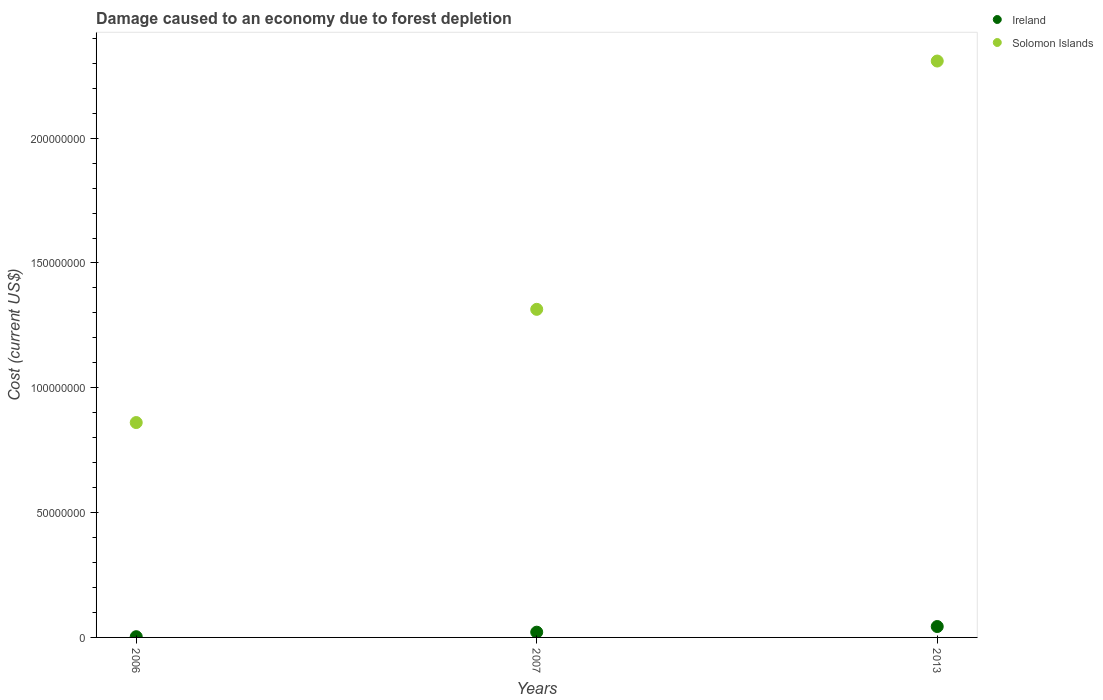Is the number of dotlines equal to the number of legend labels?
Offer a terse response. Yes. What is the cost of damage caused due to forest depletion in Ireland in 2007?
Offer a very short reply. 2.10e+06. Across all years, what is the maximum cost of damage caused due to forest depletion in Solomon Islands?
Provide a short and direct response. 2.31e+08. Across all years, what is the minimum cost of damage caused due to forest depletion in Solomon Islands?
Keep it short and to the point. 8.61e+07. In which year was the cost of damage caused due to forest depletion in Ireland maximum?
Offer a very short reply. 2013. What is the total cost of damage caused due to forest depletion in Ireland in the graph?
Your response must be concise. 6.76e+06. What is the difference between the cost of damage caused due to forest depletion in Solomon Islands in 2007 and that in 2013?
Provide a short and direct response. -9.95e+07. What is the difference between the cost of damage caused due to forest depletion in Ireland in 2013 and the cost of damage caused due to forest depletion in Solomon Islands in 2007?
Keep it short and to the point. -1.27e+08. What is the average cost of damage caused due to forest depletion in Ireland per year?
Provide a succinct answer. 2.25e+06. In the year 2007, what is the difference between the cost of damage caused due to forest depletion in Ireland and cost of damage caused due to forest depletion in Solomon Islands?
Offer a terse response. -1.29e+08. In how many years, is the cost of damage caused due to forest depletion in Solomon Islands greater than 220000000 US$?
Offer a very short reply. 1. What is the ratio of the cost of damage caused due to forest depletion in Ireland in 2007 to that in 2013?
Ensure brevity in your answer.  0.48. Is the difference between the cost of damage caused due to forest depletion in Ireland in 2006 and 2007 greater than the difference between the cost of damage caused due to forest depletion in Solomon Islands in 2006 and 2007?
Keep it short and to the point. Yes. What is the difference between the highest and the second highest cost of damage caused due to forest depletion in Solomon Islands?
Keep it short and to the point. 9.95e+07. What is the difference between the highest and the lowest cost of damage caused due to forest depletion in Solomon Islands?
Make the answer very short. 1.45e+08. Does the cost of damage caused due to forest depletion in Ireland monotonically increase over the years?
Make the answer very short. Yes. Is the cost of damage caused due to forest depletion in Solomon Islands strictly greater than the cost of damage caused due to forest depletion in Ireland over the years?
Make the answer very short. Yes. Is the cost of damage caused due to forest depletion in Ireland strictly less than the cost of damage caused due to forest depletion in Solomon Islands over the years?
Give a very brief answer. Yes. How many dotlines are there?
Offer a very short reply. 2. How many years are there in the graph?
Provide a short and direct response. 3. What is the difference between two consecutive major ticks on the Y-axis?
Keep it short and to the point. 5.00e+07. Does the graph contain grids?
Provide a succinct answer. No. Where does the legend appear in the graph?
Your answer should be very brief. Top right. How many legend labels are there?
Your answer should be very brief. 2. What is the title of the graph?
Give a very brief answer. Damage caused to an economy due to forest depletion. What is the label or title of the X-axis?
Ensure brevity in your answer.  Years. What is the label or title of the Y-axis?
Keep it short and to the point. Cost (current US$). What is the Cost (current US$) in Ireland in 2006?
Ensure brevity in your answer.  2.94e+05. What is the Cost (current US$) of Solomon Islands in 2006?
Keep it short and to the point. 8.61e+07. What is the Cost (current US$) of Ireland in 2007?
Keep it short and to the point. 2.10e+06. What is the Cost (current US$) of Solomon Islands in 2007?
Give a very brief answer. 1.31e+08. What is the Cost (current US$) in Ireland in 2013?
Provide a succinct answer. 4.37e+06. What is the Cost (current US$) in Solomon Islands in 2013?
Provide a succinct answer. 2.31e+08. Across all years, what is the maximum Cost (current US$) in Ireland?
Keep it short and to the point. 4.37e+06. Across all years, what is the maximum Cost (current US$) in Solomon Islands?
Your answer should be very brief. 2.31e+08. Across all years, what is the minimum Cost (current US$) in Ireland?
Your answer should be very brief. 2.94e+05. Across all years, what is the minimum Cost (current US$) in Solomon Islands?
Provide a short and direct response. 8.61e+07. What is the total Cost (current US$) of Ireland in the graph?
Give a very brief answer. 6.76e+06. What is the total Cost (current US$) of Solomon Islands in the graph?
Ensure brevity in your answer.  4.48e+08. What is the difference between the Cost (current US$) of Ireland in 2006 and that in 2007?
Provide a short and direct response. -1.81e+06. What is the difference between the Cost (current US$) in Solomon Islands in 2006 and that in 2007?
Your answer should be very brief. -4.54e+07. What is the difference between the Cost (current US$) in Ireland in 2006 and that in 2013?
Give a very brief answer. -4.07e+06. What is the difference between the Cost (current US$) of Solomon Islands in 2006 and that in 2013?
Offer a very short reply. -1.45e+08. What is the difference between the Cost (current US$) in Ireland in 2007 and that in 2013?
Ensure brevity in your answer.  -2.27e+06. What is the difference between the Cost (current US$) in Solomon Islands in 2007 and that in 2013?
Your answer should be compact. -9.95e+07. What is the difference between the Cost (current US$) in Ireland in 2006 and the Cost (current US$) in Solomon Islands in 2007?
Offer a very short reply. -1.31e+08. What is the difference between the Cost (current US$) of Ireland in 2006 and the Cost (current US$) of Solomon Islands in 2013?
Your answer should be very brief. -2.31e+08. What is the difference between the Cost (current US$) of Ireland in 2007 and the Cost (current US$) of Solomon Islands in 2013?
Your answer should be compact. -2.29e+08. What is the average Cost (current US$) in Ireland per year?
Offer a very short reply. 2.25e+06. What is the average Cost (current US$) in Solomon Islands per year?
Make the answer very short. 1.49e+08. In the year 2006, what is the difference between the Cost (current US$) in Ireland and Cost (current US$) in Solomon Islands?
Offer a very short reply. -8.58e+07. In the year 2007, what is the difference between the Cost (current US$) of Ireland and Cost (current US$) of Solomon Islands?
Make the answer very short. -1.29e+08. In the year 2013, what is the difference between the Cost (current US$) of Ireland and Cost (current US$) of Solomon Islands?
Your answer should be compact. -2.27e+08. What is the ratio of the Cost (current US$) of Ireland in 2006 to that in 2007?
Give a very brief answer. 0.14. What is the ratio of the Cost (current US$) in Solomon Islands in 2006 to that in 2007?
Keep it short and to the point. 0.65. What is the ratio of the Cost (current US$) of Ireland in 2006 to that in 2013?
Make the answer very short. 0.07. What is the ratio of the Cost (current US$) in Solomon Islands in 2006 to that in 2013?
Keep it short and to the point. 0.37. What is the ratio of the Cost (current US$) of Ireland in 2007 to that in 2013?
Provide a succinct answer. 0.48. What is the ratio of the Cost (current US$) in Solomon Islands in 2007 to that in 2013?
Offer a terse response. 0.57. What is the difference between the highest and the second highest Cost (current US$) in Ireland?
Give a very brief answer. 2.27e+06. What is the difference between the highest and the second highest Cost (current US$) in Solomon Islands?
Make the answer very short. 9.95e+07. What is the difference between the highest and the lowest Cost (current US$) in Ireland?
Your response must be concise. 4.07e+06. What is the difference between the highest and the lowest Cost (current US$) of Solomon Islands?
Keep it short and to the point. 1.45e+08. 